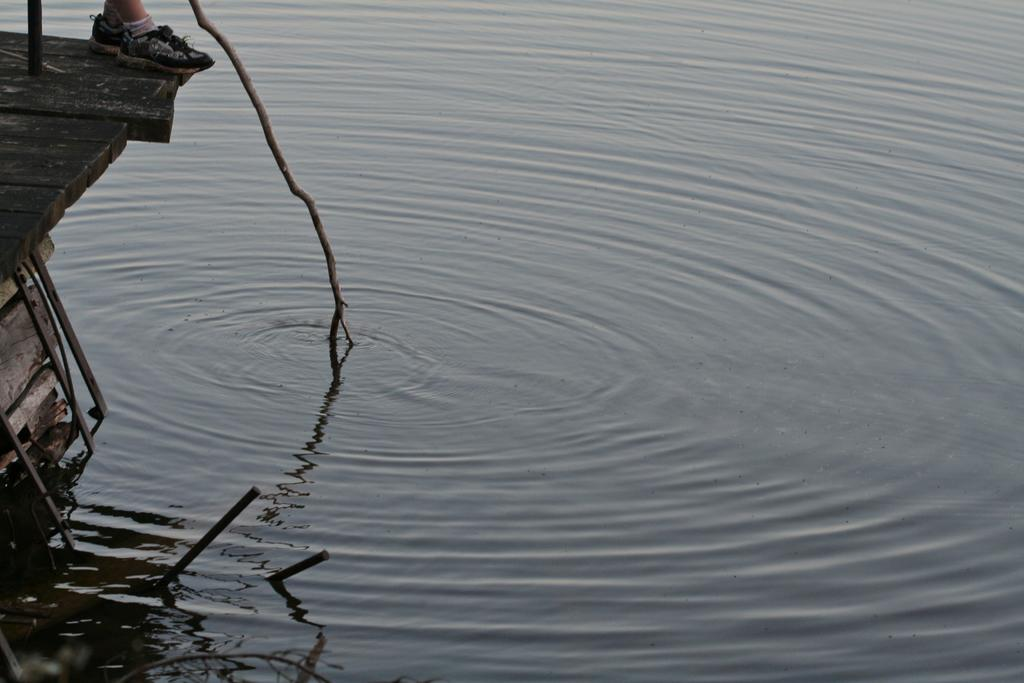What type of natural feature can be seen at the bottom of the image? There is a river at the bottom of the image. What objects are located on the left side of the image? There are wooden sticks on the left side of the image. Can you describe any human presence in the image? A person's legs are visible in the image. Where can you find a loaf of bread in the image? There is no loaf of bread present in the image. What type of park is visible in the image? There is no park visible in the image. 